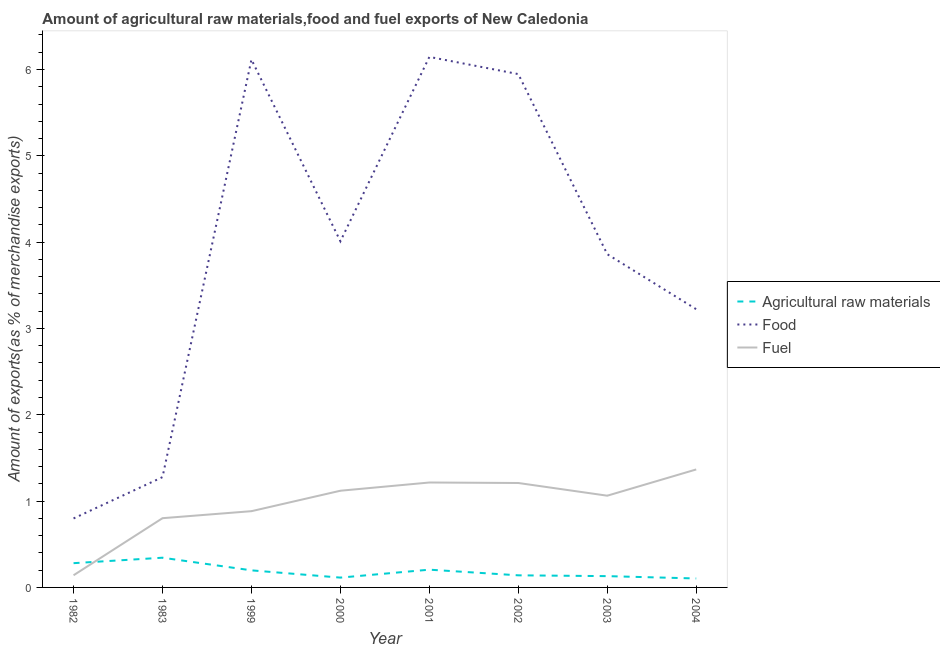How many different coloured lines are there?
Give a very brief answer. 3. Does the line corresponding to percentage of raw materials exports intersect with the line corresponding to percentage of food exports?
Keep it short and to the point. No. Is the number of lines equal to the number of legend labels?
Your answer should be compact. Yes. What is the percentage of fuel exports in 1982?
Your answer should be compact. 0.14. Across all years, what is the maximum percentage of raw materials exports?
Provide a succinct answer. 0.34. Across all years, what is the minimum percentage of raw materials exports?
Offer a terse response. 0.1. In which year was the percentage of food exports maximum?
Your answer should be compact. 2001. What is the total percentage of raw materials exports in the graph?
Provide a short and direct response. 1.52. What is the difference between the percentage of fuel exports in 2000 and that in 2004?
Ensure brevity in your answer.  -0.25. What is the difference between the percentage of raw materials exports in 2003 and the percentage of fuel exports in 2000?
Offer a very short reply. -0.99. What is the average percentage of food exports per year?
Your answer should be compact. 3.92. In the year 2001, what is the difference between the percentage of raw materials exports and percentage of fuel exports?
Make the answer very short. -1.01. In how many years, is the percentage of food exports greater than 1 %?
Provide a short and direct response. 7. What is the ratio of the percentage of food exports in 1999 to that in 2000?
Make the answer very short. 1.53. Is the percentage of fuel exports in 1983 less than that in 2002?
Offer a very short reply. Yes. What is the difference between the highest and the second highest percentage of food exports?
Your response must be concise. 0.03. What is the difference between the highest and the lowest percentage of raw materials exports?
Provide a short and direct response. 0.24. Is the sum of the percentage of raw materials exports in 2001 and 2002 greater than the maximum percentage of food exports across all years?
Offer a terse response. No. Does the percentage of food exports monotonically increase over the years?
Your response must be concise. No. Is the percentage of raw materials exports strictly greater than the percentage of food exports over the years?
Offer a terse response. No. How many lines are there?
Your answer should be compact. 3. Are the values on the major ticks of Y-axis written in scientific E-notation?
Your answer should be very brief. No. Does the graph contain any zero values?
Your response must be concise. No. Where does the legend appear in the graph?
Ensure brevity in your answer.  Center right. How are the legend labels stacked?
Provide a succinct answer. Vertical. What is the title of the graph?
Give a very brief answer. Amount of agricultural raw materials,food and fuel exports of New Caledonia. Does "Self-employed" appear as one of the legend labels in the graph?
Your answer should be very brief. No. What is the label or title of the X-axis?
Offer a terse response. Year. What is the label or title of the Y-axis?
Give a very brief answer. Amount of exports(as % of merchandise exports). What is the Amount of exports(as % of merchandise exports) in Agricultural raw materials in 1982?
Offer a terse response. 0.28. What is the Amount of exports(as % of merchandise exports) in Food in 1982?
Make the answer very short. 0.8. What is the Amount of exports(as % of merchandise exports) in Fuel in 1982?
Ensure brevity in your answer.  0.14. What is the Amount of exports(as % of merchandise exports) in Agricultural raw materials in 1983?
Ensure brevity in your answer.  0.34. What is the Amount of exports(as % of merchandise exports) of Food in 1983?
Your answer should be very brief. 1.28. What is the Amount of exports(as % of merchandise exports) of Fuel in 1983?
Give a very brief answer. 0.8. What is the Amount of exports(as % of merchandise exports) in Agricultural raw materials in 1999?
Ensure brevity in your answer.  0.2. What is the Amount of exports(as % of merchandise exports) of Food in 1999?
Ensure brevity in your answer.  6.12. What is the Amount of exports(as % of merchandise exports) in Fuel in 1999?
Offer a very short reply. 0.88. What is the Amount of exports(as % of merchandise exports) of Agricultural raw materials in 2000?
Your answer should be very brief. 0.11. What is the Amount of exports(as % of merchandise exports) in Food in 2000?
Provide a short and direct response. 4.01. What is the Amount of exports(as % of merchandise exports) of Fuel in 2000?
Your answer should be compact. 1.12. What is the Amount of exports(as % of merchandise exports) of Agricultural raw materials in 2001?
Provide a short and direct response. 0.21. What is the Amount of exports(as % of merchandise exports) in Food in 2001?
Keep it short and to the point. 6.15. What is the Amount of exports(as % of merchandise exports) in Fuel in 2001?
Keep it short and to the point. 1.22. What is the Amount of exports(as % of merchandise exports) in Agricultural raw materials in 2002?
Provide a succinct answer. 0.14. What is the Amount of exports(as % of merchandise exports) of Food in 2002?
Ensure brevity in your answer.  5.95. What is the Amount of exports(as % of merchandise exports) in Fuel in 2002?
Your answer should be compact. 1.21. What is the Amount of exports(as % of merchandise exports) in Agricultural raw materials in 2003?
Provide a succinct answer. 0.13. What is the Amount of exports(as % of merchandise exports) of Food in 2003?
Give a very brief answer. 3.86. What is the Amount of exports(as % of merchandise exports) in Fuel in 2003?
Provide a succinct answer. 1.06. What is the Amount of exports(as % of merchandise exports) in Agricultural raw materials in 2004?
Ensure brevity in your answer.  0.1. What is the Amount of exports(as % of merchandise exports) of Food in 2004?
Your response must be concise. 3.22. What is the Amount of exports(as % of merchandise exports) in Fuel in 2004?
Offer a very short reply. 1.37. Across all years, what is the maximum Amount of exports(as % of merchandise exports) in Agricultural raw materials?
Ensure brevity in your answer.  0.34. Across all years, what is the maximum Amount of exports(as % of merchandise exports) of Food?
Your answer should be compact. 6.15. Across all years, what is the maximum Amount of exports(as % of merchandise exports) in Fuel?
Provide a short and direct response. 1.37. Across all years, what is the minimum Amount of exports(as % of merchandise exports) in Agricultural raw materials?
Your answer should be compact. 0.1. Across all years, what is the minimum Amount of exports(as % of merchandise exports) of Food?
Your response must be concise. 0.8. Across all years, what is the minimum Amount of exports(as % of merchandise exports) in Fuel?
Give a very brief answer. 0.14. What is the total Amount of exports(as % of merchandise exports) of Agricultural raw materials in the graph?
Ensure brevity in your answer.  1.52. What is the total Amount of exports(as % of merchandise exports) of Food in the graph?
Keep it short and to the point. 31.38. What is the total Amount of exports(as % of merchandise exports) of Fuel in the graph?
Give a very brief answer. 7.8. What is the difference between the Amount of exports(as % of merchandise exports) in Agricultural raw materials in 1982 and that in 1983?
Make the answer very short. -0.06. What is the difference between the Amount of exports(as % of merchandise exports) of Food in 1982 and that in 1983?
Offer a terse response. -0.48. What is the difference between the Amount of exports(as % of merchandise exports) of Fuel in 1982 and that in 1983?
Offer a very short reply. -0.66. What is the difference between the Amount of exports(as % of merchandise exports) of Agricultural raw materials in 1982 and that in 1999?
Offer a very short reply. 0.08. What is the difference between the Amount of exports(as % of merchandise exports) in Food in 1982 and that in 1999?
Offer a terse response. -5.32. What is the difference between the Amount of exports(as % of merchandise exports) in Fuel in 1982 and that in 1999?
Offer a terse response. -0.74. What is the difference between the Amount of exports(as % of merchandise exports) in Agricultural raw materials in 1982 and that in 2000?
Your response must be concise. 0.17. What is the difference between the Amount of exports(as % of merchandise exports) in Food in 1982 and that in 2000?
Give a very brief answer. -3.21. What is the difference between the Amount of exports(as % of merchandise exports) of Fuel in 1982 and that in 2000?
Provide a succinct answer. -0.98. What is the difference between the Amount of exports(as % of merchandise exports) in Agricultural raw materials in 1982 and that in 2001?
Provide a short and direct response. 0.08. What is the difference between the Amount of exports(as % of merchandise exports) of Food in 1982 and that in 2001?
Ensure brevity in your answer.  -5.35. What is the difference between the Amount of exports(as % of merchandise exports) in Fuel in 1982 and that in 2001?
Give a very brief answer. -1.07. What is the difference between the Amount of exports(as % of merchandise exports) in Agricultural raw materials in 1982 and that in 2002?
Your response must be concise. 0.14. What is the difference between the Amount of exports(as % of merchandise exports) in Food in 1982 and that in 2002?
Ensure brevity in your answer.  -5.15. What is the difference between the Amount of exports(as % of merchandise exports) in Fuel in 1982 and that in 2002?
Your answer should be very brief. -1.07. What is the difference between the Amount of exports(as % of merchandise exports) in Agricultural raw materials in 1982 and that in 2003?
Ensure brevity in your answer.  0.15. What is the difference between the Amount of exports(as % of merchandise exports) in Food in 1982 and that in 2003?
Give a very brief answer. -3.06. What is the difference between the Amount of exports(as % of merchandise exports) of Fuel in 1982 and that in 2003?
Offer a very short reply. -0.92. What is the difference between the Amount of exports(as % of merchandise exports) of Agricultural raw materials in 1982 and that in 2004?
Offer a very short reply. 0.18. What is the difference between the Amount of exports(as % of merchandise exports) of Food in 1982 and that in 2004?
Provide a succinct answer. -2.42. What is the difference between the Amount of exports(as % of merchandise exports) in Fuel in 1982 and that in 2004?
Offer a very short reply. -1.23. What is the difference between the Amount of exports(as % of merchandise exports) in Agricultural raw materials in 1983 and that in 1999?
Offer a terse response. 0.15. What is the difference between the Amount of exports(as % of merchandise exports) in Food in 1983 and that in 1999?
Provide a short and direct response. -4.84. What is the difference between the Amount of exports(as % of merchandise exports) of Fuel in 1983 and that in 1999?
Offer a very short reply. -0.08. What is the difference between the Amount of exports(as % of merchandise exports) in Agricultural raw materials in 1983 and that in 2000?
Keep it short and to the point. 0.23. What is the difference between the Amount of exports(as % of merchandise exports) in Food in 1983 and that in 2000?
Provide a short and direct response. -2.73. What is the difference between the Amount of exports(as % of merchandise exports) in Fuel in 1983 and that in 2000?
Your response must be concise. -0.32. What is the difference between the Amount of exports(as % of merchandise exports) in Agricultural raw materials in 1983 and that in 2001?
Your response must be concise. 0.14. What is the difference between the Amount of exports(as % of merchandise exports) in Food in 1983 and that in 2001?
Your response must be concise. -4.87. What is the difference between the Amount of exports(as % of merchandise exports) in Fuel in 1983 and that in 2001?
Keep it short and to the point. -0.41. What is the difference between the Amount of exports(as % of merchandise exports) in Agricultural raw materials in 1983 and that in 2002?
Your answer should be very brief. 0.2. What is the difference between the Amount of exports(as % of merchandise exports) in Food in 1983 and that in 2002?
Keep it short and to the point. -4.67. What is the difference between the Amount of exports(as % of merchandise exports) of Fuel in 1983 and that in 2002?
Keep it short and to the point. -0.41. What is the difference between the Amount of exports(as % of merchandise exports) in Agricultural raw materials in 1983 and that in 2003?
Provide a succinct answer. 0.21. What is the difference between the Amount of exports(as % of merchandise exports) in Food in 1983 and that in 2003?
Provide a short and direct response. -2.58. What is the difference between the Amount of exports(as % of merchandise exports) of Fuel in 1983 and that in 2003?
Offer a terse response. -0.26. What is the difference between the Amount of exports(as % of merchandise exports) of Agricultural raw materials in 1983 and that in 2004?
Offer a terse response. 0.24. What is the difference between the Amount of exports(as % of merchandise exports) in Food in 1983 and that in 2004?
Make the answer very short. -1.95. What is the difference between the Amount of exports(as % of merchandise exports) of Fuel in 1983 and that in 2004?
Keep it short and to the point. -0.56. What is the difference between the Amount of exports(as % of merchandise exports) in Agricultural raw materials in 1999 and that in 2000?
Ensure brevity in your answer.  0.08. What is the difference between the Amount of exports(as % of merchandise exports) of Food in 1999 and that in 2000?
Keep it short and to the point. 2.11. What is the difference between the Amount of exports(as % of merchandise exports) of Fuel in 1999 and that in 2000?
Keep it short and to the point. -0.24. What is the difference between the Amount of exports(as % of merchandise exports) of Agricultural raw materials in 1999 and that in 2001?
Give a very brief answer. -0.01. What is the difference between the Amount of exports(as % of merchandise exports) of Food in 1999 and that in 2001?
Your answer should be compact. -0.03. What is the difference between the Amount of exports(as % of merchandise exports) of Fuel in 1999 and that in 2001?
Make the answer very short. -0.33. What is the difference between the Amount of exports(as % of merchandise exports) in Agricultural raw materials in 1999 and that in 2002?
Ensure brevity in your answer.  0.06. What is the difference between the Amount of exports(as % of merchandise exports) in Food in 1999 and that in 2002?
Make the answer very short. 0.17. What is the difference between the Amount of exports(as % of merchandise exports) of Fuel in 1999 and that in 2002?
Provide a short and direct response. -0.33. What is the difference between the Amount of exports(as % of merchandise exports) in Agricultural raw materials in 1999 and that in 2003?
Provide a short and direct response. 0.07. What is the difference between the Amount of exports(as % of merchandise exports) in Food in 1999 and that in 2003?
Your answer should be compact. 2.26. What is the difference between the Amount of exports(as % of merchandise exports) of Fuel in 1999 and that in 2003?
Make the answer very short. -0.18. What is the difference between the Amount of exports(as % of merchandise exports) of Agricultural raw materials in 1999 and that in 2004?
Provide a short and direct response. 0.09. What is the difference between the Amount of exports(as % of merchandise exports) of Food in 1999 and that in 2004?
Make the answer very short. 2.89. What is the difference between the Amount of exports(as % of merchandise exports) of Fuel in 1999 and that in 2004?
Give a very brief answer. -0.48. What is the difference between the Amount of exports(as % of merchandise exports) of Agricultural raw materials in 2000 and that in 2001?
Your answer should be very brief. -0.09. What is the difference between the Amount of exports(as % of merchandise exports) of Food in 2000 and that in 2001?
Your answer should be very brief. -2.14. What is the difference between the Amount of exports(as % of merchandise exports) of Fuel in 2000 and that in 2001?
Make the answer very short. -0.1. What is the difference between the Amount of exports(as % of merchandise exports) in Agricultural raw materials in 2000 and that in 2002?
Make the answer very short. -0.03. What is the difference between the Amount of exports(as % of merchandise exports) in Food in 2000 and that in 2002?
Provide a short and direct response. -1.94. What is the difference between the Amount of exports(as % of merchandise exports) in Fuel in 2000 and that in 2002?
Provide a succinct answer. -0.09. What is the difference between the Amount of exports(as % of merchandise exports) in Agricultural raw materials in 2000 and that in 2003?
Your response must be concise. -0.02. What is the difference between the Amount of exports(as % of merchandise exports) of Food in 2000 and that in 2003?
Your answer should be very brief. 0.15. What is the difference between the Amount of exports(as % of merchandise exports) in Fuel in 2000 and that in 2003?
Ensure brevity in your answer.  0.06. What is the difference between the Amount of exports(as % of merchandise exports) of Agricultural raw materials in 2000 and that in 2004?
Ensure brevity in your answer.  0.01. What is the difference between the Amount of exports(as % of merchandise exports) in Food in 2000 and that in 2004?
Give a very brief answer. 0.79. What is the difference between the Amount of exports(as % of merchandise exports) of Fuel in 2000 and that in 2004?
Your answer should be very brief. -0.25. What is the difference between the Amount of exports(as % of merchandise exports) of Agricultural raw materials in 2001 and that in 2002?
Your answer should be very brief. 0.07. What is the difference between the Amount of exports(as % of merchandise exports) in Food in 2001 and that in 2002?
Make the answer very short. 0.2. What is the difference between the Amount of exports(as % of merchandise exports) in Fuel in 2001 and that in 2002?
Your response must be concise. 0.01. What is the difference between the Amount of exports(as % of merchandise exports) in Agricultural raw materials in 2001 and that in 2003?
Give a very brief answer. 0.07. What is the difference between the Amount of exports(as % of merchandise exports) in Food in 2001 and that in 2003?
Offer a very short reply. 2.29. What is the difference between the Amount of exports(as % of merchandise exports) of Fuel in 2001 and that in 2003?
Offer a very short reply. 0.15. What is the difference between the Amount of exports(as % of merchandise exports) in Agricultural raw materials in 2001 and that in 2004?
Your response must be concise. 0.1. What is the difference between the Amount of exports(as % of merchandise exports) of Food in 2001 and that in 2004?
Give a very brief answer. 2.92. What is the difference between the Amount of exports(as % of merchandise exports) in Fuel in 2001 and that in 2004?
Offer a very short reply. -0.15. What is the difference between the Amount of exports(as % of merchandise exports) of Agricultural raw materials in 2002 and that in 2003?
Provide a short and direct response. 0.01. What is the difference between the Amount of exports(as % of merchandise exports) in Food in 2002 and that in 2003?
Your answer should be compact. 2.09. What is the difference between the Amount of exports(as % of merchandise exports) of Fuel in 2002 and that in 2003?
Keep it short and to the point. 0.15. What is the difference between the Amount of exports(as % of merchandise exports) in Agricultural raw materials in 2002 and that in 2004?
Provide a short and direct response. 0.04. What is the difference between the Amount of exports(as % of merchandise exports) in Food in 2002 and that in 2004?
Give a very brief answer. 2.72. What is the difference between the Amount of exports(as % of merchandise exports) in Fuel in 2002 and that in 2004?
Ensure brevity in your answer.  -0.16. What is the difference between the Amount of exports(as % of merchandise exports) of Agricultural raw materials in 2003 and that in 2004?
Provide a succinct answer. 0.03. What is the difference between the Amount of exports(as % of merchandise exports) of Food in 2003 and that in 2004?
Offer a terse response. 0.64. What is the difference between the Amount of exports(as % of merchandise exports) of Fuel in 2003 and that in 2004?
Offer a very short reply. -0.3. What is the difference between the Amount of exports(as % of merchandise exports) of Agricultural raw materials in 1982 and the Amount of exports(as % of merchandise exports) of Food in 1983?
Give a very brief answer. -1. What is the difference between the Amount of exports(as % of merchandise exports) in Agricultural raw materials in 1982 and the Amount of exports(as % of merchandise exports) in Fuel in 1983?
Offer a very short reply. -0.52. What is the difference between the Amount of exports(as % of merchandise exports) of Food in 1982 and the Amount of exports(as % of merchandise exports) of Fuel in 1983?
Offer a terse response. -0. What is the difference between the Amount of exports(as % of merchandise exports) in Agricultural raw materials in 1982 and the Amount of exports(as % of merchandise exports) in Food in 1999?
Provide a short and direct response. -5.83. What is the difference between the Amount of exports(as % of merchandise exports) in Agricultural raw materials in 1982 and the Amount of exports(as % of merchandise exports) in Fuel in 1999?
Keep it short and to the point. -0.6. What is the difference between the Amount of exports(as % of merchandise exports) of Food in 1982 and the Amount of exports(as % of merchandise exports) of Fuel in 1999?
Keep it short and to the point. -0.08. What is the difference between the Amount of exports(as % of merchandise exports) in Agricultural raw materials in 1982 and the Amount of exports(as % of merchandise exports) in Food in 2000?
Your answer should be compact. -3.73. What is the difference between the Amount of exports(as % of merchandise exports) of Agricultural raw materials in 1982 and the Amount of exports(as % of merchandise exports) of Fuel in 2000?
Give a very brief answer. -0.84. What is the difference between the Amount of exports(as % of merchandise exports) of Food in 1982 and the Amount of exports(as % of merchandise exports) of Fuel in 2000?
Keep it short and to the point. -0.32. What is the difference between the Amount of exports(as % of merchandise exports) of Agricultural raw materials in 1982 and the Amount of exports(as % of merchandise exports) of Food in 2001?
Your response must be concise. -5.87. What is the difference between the Amount of exports(as % of merchandise exports) in Agricultural raw materials in 1982 and the Amount of exports(as % of merchandise exports) in Fuel in 2001?
Give a very brief answer. -0.93. What is the difference between the Amount of exports(as % of merchandise exports) of Food in 1982 and the Amount of exports(as % of merchandise exports) of Fuel in 2001?
Ensure brevity in your answer.  -0.42. What is the difference between the Amount of exports(as % of merchandise exports) of Agricultural raw materials in 1982 and the Amount of exports(as % of merchandise exports) of Food in 2002?
Offer a very short reply. -5.67. What is the difference between the Amount of exports(as % of merchandise exports) in Agricultural raw materials in 1982 and the Amount of exports(as % of merchandise exports) in Fuel in 2002?
Offer a very short reply. -0.93. What is the difference between the Amount of exports(as % of merchandise exports) in Food in 1982 and the Amount of exports(as % of merchandise exports) in Fuel in 2002?
Offer a very short reply. -0.41. What is the difference between the Amount of exports(as % of merchandise exports) of Agricultural raw materials in 1982 and the Amount of exports(as % of merchandise exports) of Food in 2003?
Your response must be concise. -3.58. What is the difference between the Amount of exports(as % of merchandise exports) of Agricultural raw materials in 1982 and the Amount of exports(as % of merchandise exports) of Fuel in 2003?
Give a very brief answer. -0.78. What is the difference between the Amount of exports(as % of merchandise exports) of Food in 1982 and the Amount of exports(as % of merchandise exports) of Fuel in 2003?
Ensure brevity in your answer.  -0.26. What is the difference between the Amount of exports(as % of merchandise exports) of Agricultural raw materials in 1982 and the Amount of exports(as % of merchandise exports) of Food in 2004?
Ensure brevity in your answer.  -2.94. What is the difference between the Amount of exports(as % of merchandise exports) in Agricultural raw materials in 1982 and the Amount of exports(as % of merchandise exports) in Fuel in 2004?
Provide a short and direct response. -1.09. What is the difference between the Amount of exports(as % of merchandise exports) of Food in 1982 and the Amount of exports(as % of merchandise exports) of Fuel in 2004?
Your answer should be compact. -0.57. What is the difference between the Amount of exports(as % of merchandise exports) in Agricultural raw materials in 1983 and the Amount of exports(as % of merchandise exports) in Food in 1999?
Offer a terse response. -5.77. What is the difference between the Amount of exports(as % of merchandise exports) of Agricultural raw materials in 1983 and the Amount of exports(as % of merchandise exports) of Fuel in 1999?
Your answer should be very brief. -0.54. What is the difference between the Amount of exports(as % of merchandise exports) in Food in 1983 and the Amount of exports(as % of merchandise exports) in Fuel in 1999?
Give a very brief answer. 0.39. What is the difference between the Amount of exports(as % of merchandise exports) in Agricultural raw materials in 1983 and the Amount of exports(as % of merchandise exports) in Food in 2000?
Offer a terse response. -3.67. What is the difference between the Amount of exports(as % of merchandise exports) in Agricultural raw materials in 1983 and the Amount of exports(as % of merchandise exports) in Fuel in 2000?
Ensure brevity in your answer.  -0.78. What is the difference between the Amount of exports(as % of merchandise exports) in Food in 1983 and the Amount of exports(as % of merchandise exports) in Fuel in 2000?
Your answer should be very brief. 0.16. What is the difference between the Amount of exports(as % of merchandise exports) of Agricultural raw materials in 1983 and the Amount of exports(as % of merchandise exports) of Food in 2001?
Your response must be concise. -5.8. What is the difference between the Amount of exports(as % of merchandise exports) in Agricultural raw materials in 1983 and the Amount of exports(as % of merchandise exports) in Fuel in 2001?
Provide a succinct answer. -0.87. What is the difference between the Amount of exports(as % of merchandise exports) in Food in 1983 and the Amount of exports(as % of merchandise exports) in Fuel in 2001?
Keep it short and to the point. 0.06. What is the difference between the Amount of exports(as % of merchandise exports) in Agricultural raw materials in 1983 and the Amount of exports(as % of merchandise exports) in Food in 2002?
Provide a succinct answer. -5.6. What is the difference between the Amount of exports(as % of merchandise exports) in Agricultural raw materials in 1983 and the Amount of exports(as % of merchandise exports) in Fuel in 2002?
Your answer should be compact. -0.87. What is the difference between the Amount of exports(as % of merchandise exports) in Food in 1983 and the Amount of exports(as % of merchandise exports) in Fuel in 2002?
Your answer should be compact. 0.07. What is the difference between the Amount of exports(as % of merchandise exports) in Agricultural raw materials in 1983 and the Amount of exports(as % of merchandise exports) in Food in 2003?
Provide a succinct answer. -3.52. What is the difference between the Amount of exports(as % of merchandise exports) of Agricultural raw materials in 1983 and the Amount of exports(as % of merchandise exports) of Fuel in 2003?
Keep it short and to the point. -0.72. What is the difference between the Amount of exports(as % of merchandise exports) of Food in 1983 and the Amount of exports(as % of merchandise exports) of Fuel in 2003?
Give a very brief answer. 0.22. What is the difference between the Amount of exports(as % of merchandise exports) in Agricultural raw materials in 1983 and the Amount of exports(as % of merchandise exports) in Food in 2004?
Your answer should be compact. -2.88. What is the difference between the Amount of exports(as % of merchandise exports) of Agricultural raw materials in 1983 and the Amount of exports(as % of merchandise exports) of Fuel in 2004?
Provide a succinct answer. -1.02. What is the difference between the Amount of exports(as % of merchandise exports) in Food in 1983 and the Amount of exports(as % of merchandise exports) in Fuel in 2004?
Give a very brief answer. -0.09. What is the difference between the Amount of exports(as % of merchandise exports) in Agricultural raw materials in 1999 and the Amount of exports(as % of merchandise exports) in Food in 2000?
Keep it short and to the point. -3.81. What is the difference between the Amount of exports(as % of merchandise exports) of Agricultural raw materials in 1999 and the Amount of exports(as % of merchandise exports) of Fuel in 2000?
Provide a succinct answer. -0.92. What is the difference between the Amount of exports(as % of merchandise exports) in Food in 1999 and the Amount of exports(as % of merchandise exports) in Fuel in 2000?
Ensure brevity in your answer.  5. What is the difference between the Amount of exports(as % of merchandise exports) in Agricultural raw materials in 1999 and the Amount of exports(as % of merchandise exports) in Food in 2001?
Ensure brevity in your answer.  -5.95. What is the difference between the Amount of exports(as % of merchandise exports) of Agricultural raw materials in 1999 and the Amount of exports(as % of merchandise exports) of Fuel in 2001?
Your answer should be compact. -1.02. What is the difference between the Amount of exports(as % of merchandise exports) in Food in 1999 and the Amount of exports(as % of merchandise exports) in Fuel in 2001?
Offer a very short reply. 4.9. What is the difference between the Amount of exports(as % of merchandise exports) of Agricultural raw materials in 1999 and the Amount of exports(as % of merchandise exports) of Food in 2002?
Provide a succinct answer. -5.75. What is the difference between the Amount of exports(as % of merchandise exports) in Agricultural raw materials in 1999 and the Amount of exports(as % of merchandise exports) in Fuel in 2002?
Provide a short and direct response. -1.01. What is the difference between the Amount of exports(as % of merchandise exports) in Food in 1999 and the Amount of exports(as % of merchandise exports) in Fuel in 2002?
Your answer should be compact. 4.91. What is the difference between the Amount of exports(as % of merchandise exports) of Agricultural raw materials in 1999 and the Amount of exports(as % of merchandise exports) of Food in 2003?
Your answer should be very brief. -3.66. What is the difference between the Amount of exports(as % of merchandise exports) in Agricultural raw materials in 1999 and the Amount of exports(as % of merchandise exports) in Fuel in 2003?
Your response must be concise. -0.86. What is the difference between the Amount of exports(as % of merchandise exports) of Food in 1999 and the Amount of exports(as % of merchandise exports) of Fuel in 2003?
Keep it short and to the point. 5.05. What is the difference between the Amount of exports(as % of merchandise exports) of Agricultural raw materials in 1999 and the Amount of exports(as % of merchandise exports) of Food in 2004?
Provide a succinct answer. -3.03. What is the difference between the Amount of exports(as % of merchandise exports) in Agricultural raw materials in 1999 and the Amount of exports(as % of merchandise exports) in Fuel in 2004?
Your answer should be compact. -1.17. What is the difference between the Amount of exports(as % of merchandise exports) of Food in 1999 and the Amount of exports(as % of merchandise exports) of Fuel in 2004?
Provide a succinct answer. 4.75. What is the difference between the Amount of exports(as % of merchandise exports) in Agricultural raw materials in 2000 and the Amount of exports(as % of merchandise exports) in Food in 2001?
Your response must be concise. -6.03. What is the difference between the Amount of exports(as % of merchandise exports) in Agricultural raw materials in 2000 and the Amount of exports(as % of merchandise exports) in Fuel in 2001?
Your response must be concise. -1.1. What is the difference between the Amount of exports(as % of merchandise exports) of Food in 2000 and the Amount of exports(as % of merchandise exports) of Fuel in 2001?
Provide a succinct answer. 2.79. What is the difference between the Amount of exports(as % of merchandise exports) in Agricultural raw materials in 2000 and the Amount of exports(as % of merchandise exports) in Food in 2002?
Ensure brevity in your answer.  -5.83. What is the difference between the Amount of exports(as % of merchandise exports) of Agricultural raw materials in 2000 and the Amount of exports(as % of merchandise exports) of Fuel in 2002?
Ensure brevity in your answer.  -1.1. What is the difference between the Amount of exports(as % of merchandise exports) in Food in 2000 and the Amount of exports(as % of merchandise exports) in Fuel in 2002?
Make the answer very short. 2.8. What is the difference between the Amount of exports(as % of merchandise exports) of Agricultural raw materials in 2000 and the Amount of exports(as % of merchandise exports) of Food in 2003?
Your answer should be very brief. -3.75. What is the difference between the Amount of exports(as % of merchandise exports) in Agricultural raw materials in 2000 and the Amount of exports(as % of merchandise exports) in Fuel in 2003?
Keep it short and to the point. -0.95. What is the difference between the Amount of exports(as % of merchandise exports) of Food in 2000 and the Amount of exports(as % of merchandise exports) of Fuel in 2003?
Provide a succinct answer. 2.95. What is the difference between the Amount of exports(as % of merchandise exports) of Agricultural raw materials in 2000 and the Amount of exports(as % of merchandise exports) of Food in 2004?
Keep it short and to the point. -3.11. What is the difference between the Amount of exports(as % of merchandise exports) of Agricultural raw materials in 2000 and the Amount of exports(as % of merchandise exports) of Fuel in 2004?
Ensure brevity in your answer.  -1.25. What is the difference between the Amount of exports(as % of merchandise exports) in Food in 2000 and the Amount of exports(as % of merchandise exports) in Fuel in 2004?
Your answer should be very brief. 2.64. What is the difference between the Amount of exports(as % of merchandise exports) in Agricultural raw materials in 2001 and the Amount of exports(as % of merchandise exports) in Food in 2002?
Make the answer very short. -5.74. What is the difference between the Amount of exports(as % of merchandise exports) in Agricultural raw materials in 2001 and the Amount of exports(as % of merchandise exports) in Fuel in 2002?
Keep it short and to the point. -1. What is the difference between the Amount of exports(as % of merchandise exports) in Food in 2001 and the Amount of exports(as % of merchandise exports) in Fuel in 2002?
Provide a succinct answer. 4.94. What is the difference between the Amount of exports(as % of merchandise exports) in Agricultural raw materials in 2001 and the Amount of exports(as % of merchandise exports) in Food in 2003?
Ensure brevity in your answer.  -3.65. What is the difference between the Amount of exports(as % of merchandise exports) of Agricultural raw materials in 2001 and the Amount of exports(as % of merchandise exports) of Fuel in 2003?
Give a very brief answer. -0.86. What is the difference between the Amount of exports(as % of merchandise exports) in Food in 2001 and the Amount of exports(as % of merchandise exports) in Fuel in 2003?
Make the answer very short. 5.08. What is the difference between the Amount of exports(as % of merchandise exports) of Agricultural raw materials in 2001 and the Amount of exports(as % of merchandise exports) of Food in 2004?
Give a very brief answer. -3.02. What is the difference between the Amount of exports(as % of merchandise exports) in Agricultural raw materials in 2001 and the Amount of exports(as % of merchandise exports) in Fuel in 2004?
Give a very brief answer. -1.16. What is the difference between the Amount of exports(as % of merchandise exports) in Food in 2001 and the Amount of exports(as % of merchandise exports) in Fuel in 2004?
Keep it short and to the point. 4.78. What is the difference between the Amount of exports(as % of merchandise exports) of Agricultural raw materials in 2002 and the Amount of exports(as % of merchandise exports) of Food in 2003?
Your answer should be very brief. -3.72. What is the difference between the Amount of exports(as % of merchandise exports) of Agricultural raw materials in 2002 and the Amount of exports(as % of merchandise exports) of Fuel in 2003?
Your answer should be compact. -0.92. What is the difference between the Amount of exports(as % of merchandise exports) of Food in 2002 and the Amount of exports(as % of merchandise exports) of Fuel in 2003?
Offer a very short reply. 4.88. What is the difference between the Amount of exports(as % of merchandise exports) of Agricultural raw materials in 2002 and the Amount of exports(as % of merchandise exports) of Food in 2004?
Provide a succinct answer. -3.08. What is the difference between the Amount of exports(as % of merchandise exports) in Agricultural raw materials in 2002 and the Amount of exports(as % of merchandise exports) in Fuel in 2004?
Your response must be concise. -1.23. What is the difference between the Amount of exports(as % of merchandise exports) in Food in 2002 and the Amount of exports(as % of merchandise exports) in Fuel in 2004?
Provide a short and direct response. 4.58. What is the difference between the Amount of exports(as % of merchandise exports) of Agricultural raw materials in 2003 and the Amount of exports(as % of merchandise exports) of Food in 2004?
Provide a succinct answer. -3.09. What is the difference between the Amount of exports(as % of merchandise exports) in Agricultural raw materials in 2003 and the Amount of exports(as % of merchandise exports) in Fuel in 2004?
Offer a very short reply. -1.24. What is the difference between the Amount of exports(as % of merchandise exports) of Food in 2003 and the Amount of exports(as % of merchandise exports) of Fuel in 2004?
Provide a succinct answer. 2.49. What is the average Amount of exports(as % of merchandise exports) of Agricultural raw materials per year?
Offer a very short reply. 0.19. What is the average Amount of exports(as % of merchandise exports) in Food per year?
Give a very brief answer. 3.92. What is the average Amount of exports(as % of merchandise exports) in Fuel per year?
Offer a terse response. 0.98. In the year 1982, what is the difference between the Amount of exports(as % of merchandise exports) in Agricultural raw materials and Amount of exports(as % of merchandise exports) in Food?
Your answer should be compact. -0.52. In the year 1982, what is the difference between the Amount of exports(as % of merchandise exports) in Agricultural raw materials and Amount of exports(as % of merchandise exports) in Fuel?
Provide a short and direct response. 0.14. In the year 1982, what is the difference between the Amount of exports(as % of merchandise exports) of Food and Amount of exports(as % of merchandise exports) of Fuel?
Ensure brevity in your answer.  0.66. In the year 1983, what is the difference between the Amount of exports(as % of merchandise exports) in Agricultural raw materials and Amount of exports(as % of merchandise exports) in Food?
Ensure brevity in your answer.  -0.93. In the year 1983, what is the difference between the Amount of exports(as % of merchandise exports) of Agricultural raw materials and Amount of exports(as % of merchandise exports) of Fuel?
Offer a terse response. -0.46. In the year 1983, what is the difference between the Amount of exports(as % of merchandise exports) of Food and Amount of exports(as % of merchandise exports) of Fuel?
Provide a succinct answer. 0.48. In the year 1999, what is the difference between the Amount of exports(as % of merchandise exports) in Agricultural raw materials and Amount of exports(as % of merchandise exports) in Food?
Your answer should be compact. -5.92. In the year 1999, what is the difference between the Amount of exports(as % of merchandise exports) in Agricultural raw materials and Amount of exports(as % of merchandise exports) in Fuel?
Your answer should be very brief. -0.69. In the year 1999, what is the difference between the Amount of exports(as % of merchandise exports) in Food and Amount of exports(as % of merchandise exports) in Fuel?
Your answer should be very brief. 5.23. In the year 2000, what is the difference between the Amount of exports(as % of merchandise exports) in Agricultural raw materials and Amount of exports(as % of merchandise exports) in Food?
Provide a succinct answer. -3.9. In the year 2000, what is the difference between the Amount of exports(as % of merchandise exports) of Agricultural raw materials and Amount of exports(as % of merchandise exports) of Fuel?
Offer a terse response. -1.01. In the year 2000, what is the difference between the Amount of exports(as % of merchandise exports) in Food and Amount of exports(as % of merchandise exports) in Fuel?
Offer a very short reply. 2.89. In the year 2001, what is the difference between the Amount of exports(as % of merchandise exports) in Agricultural raw materials and Amount of exports(as % of merchandise exports) in Food?
Offer a very short reply. -5.94. In the year 2001, what is the difference between the Amount of exports(as % of merchandise exports) in Agricultural raw materials and Amount of exports(as % of merchandise exports) in Fuel?
Offer a very short reply. -1.01. In the year 2001, what is the difference between the Amount of exports(as % of merchandise exports) of Food and Amount of exports(as % of merchandise exports) of Fuel?
Your answer should be compact. 4.93. In the year 2002, what is the difference between the Amount of exports(as % of merchandise exports) in Agricultural raw materials and Amount of exports(as % of merchandise exports) in Food?
Make the answer very short. -5.81. In the year 2002, what is the difference between the Amount of exports(as % of merchandise exports) of Agricultural raw materials and Amount of exports(as % of merchandise exports) of Fuel?
Ensure brevity in your answer.  -1.07. In the year 2002, what is the difference between the Amount of exports(as % of merchandise exports) in Food and Amount of exports(as % of merchandise exports) in Fuel?
Your answer should be very brief. 4.74. In the year 2003, what is the difference between the Amount of exports(as % of merchandise exports) of Agricultural raw materials and Amount of exports(as % of merchandise exports) of Food?
Give a very brief answer. -3.73. In the year 2003, what is the difference between the Amount of exports(as % of merchandise exports) in Agricultural raw materials and Amount of exports(as % of merchandise exports) in Fuel?
Offer a terse response. -0.93. In the year 2003, what is the difference between the Amount of exports(as % of merchandise exports) of Food and Amount of exports(as % of merchandise exports) of Fuel?
Offer a very short reply. 2.8. In the year 2004, what is the difference between the Amount of exports(as % of merchandise exports) in Agricultural raw materials and Amount of exports(as % of merchandise exports) in Food?
Make the answer very short. -3.12. In the year 2004, what is the difference between the Amount of exports(as % of merchandise exports) in Agricultural raw materials and Amount of exports(as % of merchandise exports) in Fuel?
Provide a short and direct response. -1.26. In the year 2004, what is the difference between the Amount of exports(as % of merchandise exports) in Food and Amount of exports(as % of merchandise exports) in Fuel?
Offer a terse response. 1.86. What is the ratio of the Amount of exports(as % of merchandise exports) in Agricultural raw materials in 1982 to that in 1983?
Provide a short and direct response. 0.82. What is the ratio of the Amount of exports(as % of merchandise exports) in Food in 1982 to that in 1983?
Your answer should be compact. 0.63. What is the ratio of the Amount of exports(as % of merchandise exports) in Fuel in 1982 to that in 1983?
Keep it short and to the point. 0.18. What is the ratio of the Amount of exports(as % of merchandise exports) in Agricultural raw materials in 1982 to that in 1999?
Offer a very short reply. 1.42. What is the ratio of the Amount of exports(as % of merchandise exports) in Food in 1982 to that in 1999?
Provide a short and direct response. 0.13. What is the ratio of the Amount of exports(as % of merchandise exports) in Fuel in 1982 to that in 1999?
Your answer should be compact. 0.16. What is the ratio of the Amount of exports(as % of merchandise exports) of Agricultural raw materials in 1982 to that in 2000?
Your answer should be compact. 2.47. What is the ratio of the Amount of exports(as % of merchandise exports) of Food in 1982 to that in 2000?
Offer a very short reply. 0.2. What is the ratio of the Amount of exports(as % of merchandise exports) in Fuel in 1982 to that in 2000?
Offer a terse response. 0.13. What is the ratio of the Amount of exports(as % of merchandise exports) in Agricultural raw materials in 1982 to that in 2001?
Provide a succinct answer. 1.37. What is the ratio of the Amount of exports(as % of merchandise exports) in Food in 1982 to that in 2001?
Your response must be concise. 0.13. What is the ratio of the Amount of exports(as % of merchandise exports) of Fuel in 1982 to that in 2001?
Provide a succinct answer. 0.12. What is the ratio of the Amount of exports(as % of merchandise exports) in Agricultural raw materials in 1982 to that in 2002?
Offer a terse response. 2. What is the ratio of the Amount of exports(as % of merchandise exports) in Food in 1982 to that in 2002?
Offer a very short reply. 0.13. What is the ratio of the Amount of exports(as % of merchandise exports) of Fuel in 1982 to that in 2002?
Provide a short and direct response. 0.12. What is the ratio of the Amount of exports(as % of merchandise exports) of Agricultural raw materials in 1982 to that in 2003?
Your answer should be compact. 2.15. What is the ratio of the Amount of exports(as % of merchandise exports) of Food in 1982 to that in 2003?
Your answer should be very brief. 0.21. What is the ratio of the Amount of exports(as % of merchandise exports) in Fuel in 1982 to that in 2003?
Give a very brief answer. 0.13. What is the ratio of the Amount of exports(as % of merchandise exports) in Agricultural raw materials in 1982 to that in 2004?
Offer a very short reply. 2.71. What is the ratio of the Amount of exports(as % of merchandise exports) in Food in 1982 to that in 2004?
Your response must be concise. 0.25. What is the ratio of the Amount of exports(as % of merchandise exports) in Fuel in 1982 to that in 2004?
Make the answer very short. 0.1. What is the ratio of the Amount of exports(as % of merchandise exports) in Agricultural raw materials in 1983 to that in 1999?
Keep it short and to the point. 1.74. What is the ratio of the Amount of exports(as % of merchandise exports) in Food in 1983 to that in 1999?
Your response must be concise. 0.21. What is the ratio of the Amount of exports(as % of merchandise exports) of Fuel in 1983 to that in 1999?
Your answer should be very brief. 0.91. What is the ratio of the Amount of exports(as % of merchandise exports) in Agricultural raw materials in 1983 to that in 2000?
Your answer should be very brief. 3.03. What is the ratio of the Amount of exports(as % of merchandise exports) of Food in 1983 to that in 2000?
Your answer should be compact. 0.32. What is the ratio of the Amount of exports(as % of merchandise exports) in Fuel in 1983 to that in 2000?
Keep it short and to the point. 0.72. What is the ratio of the Amount of exports(as % of merchandise exports) of Agricultural raw materials in 1983 to that in 2001?
Offer a terse response. 1.67. What is the ratio of the Amount of exports(as % of merchandise exports) of Food in 1983 to that in 2001?
Provide a succinct answer. 0.21. What is the ratio of the Amount of exports(as % of merchandise exports) of Fuel in 1983 to that in 2001?
Ensure brevity in your answer.  0.66. What is the ratio of the Amount of exports(as % of merchandise exports) of Agricultural raw materials in 1983 to that in 2002?
Provide a short and direct response. 2.46. What is the ratio of the Amount of exports(as % of merchandise exports) in Food in 1983 to that in 2002?
Provide a succinct answer. 0.21. What is the ratio of the Amount of exports(as % of merchandise exports) in Fuel in 1983 to that in 2002?
Your answer should be compact. 0.66. What is the ratio of the Amount of exports(as % of merchandise exports) of Agricultural raw materials in 1983 to that in 2003?
Offer a terse response. 2.63. What is the ratio of the Amount of exports(as % of merchandise exports) in Food in 1983 to that in 2003?
Provide a succinct answer. 0.33. What is the ratio of the Amount of exports(as % of merchandise exports) in Fuel in 1983 to that in 2003?
Give a very brief answer. 0.75. What is the ratio of the Amount of exports(as % of merchandise exports) in Agricultural raw materials in 1983 to that in 2004?
Give a very brief answer. 3.32. What is the ratio of the Amount of exports(as % of merchandise exports) of Food in 1983 to that in 2004?
Your answer should be very brief. 0.4. What is the ratio of the Amount of exports(as % of merchandise exports) of Fuel in 1983 to that in 2004?
Ensure brevity in your answer.  0.59. What is the ratio of the Amount of exports(as % of merchandise exports) in Agricultural raw materials in 1999 to that in 2000?
Your answer should be very brief. 1.74. What is the ratio of the Amount of exports(as % of merchandise exports) in Food in 1999 to that in 2000?
Ensure brevity in your answer.  1.53. What is the ratio of the Amount of exports(as % of merchandise exports) of Fuel in 1999 to that in 2000?
Your response must be concise. 0.79. What is the ratio of the Amount of exports(as % of merchandise exports) of Agricultural raw materials in 1999 to that in 2001?
Your answer should be very brief. 0.96. What is the ratio of the Amount of exports(as % of merchandise exports) in Food in 1999 to that in 2001?
Your answer should be very brief. 1. What is the ratio of the Amount of exports(as % of merchandise exports) in Fuel in 1999 to that in 2001?
Keep it short and to the point. 0.73. What is the ratio of the Amount of exports(as % of merchandise exports) of Agricultural raw materials in 1999 to that in 2002?
Give a very brief answer. 1.41. What is the ratio of the Amount of exports(as % of merchandise exports) in Food in 1999 to that in 2002?
Provide a short and direct response. 1.03. What is the ratio of the Amount of exports(as % of merchandise exports) in Fuel in 1999 to that in 2002?
Your response must be concise. 0.73. What is the ratio of the Amount of exports(as % of merchandise exports) in Agricultural raw materials in 1999 to that in 2003?
Your answer should be compact. 1.51. What is the ratio of the Amount of exports(as % of merchandise exports) in Food in 1999 to that in 2003?
Provide a short and direct response. 1.58. What is the ratio of the Amount of exports(as % of merchandise exports) in Fuel in 1999 to that in 2003?
Give a very brief answer. 0.83. What is the ratio of the Amount of exports(as % of merchandise exports) in Agricultural raw materials in 1999 to that in 2004?
Your answer should be very brief. 1.91. What is the ratio of the Amount of exports(as % of merchandise exports) in Food in 1999 to that in 2004?
Your response must be concise. 1.9. What is the ratio of the Amount of exports(as % of merchandise exports) of Fuel in 1999 to that in 2004?
Make the answer very short. 0.65. What is the ratio of the Amount of exports(as % of merchandise exports) in Agricultural raw materials in 2000 to that in 2001?
Offer a terse response. 0.55. What is the ratio of the Amount of exports(as % of merchandise exports) in Food in 2000 to that in 2001?
Give a very brief answer. 0.65. What is the ratio of the Amount of exports(as % of merchandise exports) of Fuel in 2000 to that in 2001?
Make the answer very short. 0.92. What is the ratio of the Amount of exports(as % of merchandise exports) of Agricultural raw materials in 2000 to that in 2002?
Ensure brevity in your answer.  0.81. What is the ratio of the Amount of exports(as % of merchandise exports) in Food in 2000 to that in 2002?
Provide a succinct answer. 0.67. What is the ratio of the Amount of exports(as % of merchandise exports) in Fuel in 2000 to that in 2002?
Your answer should be very brief. 0.93. What is the ratio of the Amount of exports(as % of merchandise exports) in Agricultural raw materials in 2000 to that in 2003?
Give a very brief answer. 0.87. What is the ratio of the Amount of exports(as % of merchandise exports) of Food in 2000 to that in 2003?
Keep it short and to the point. 1.04. What is the ratio of the Amount of exports(as % of merchandise exports) in Fuel in 2000 to that in 2003?
Keep it short and to the point. 1.05. What is the ratio of the Amount of exports(as % of merchandise exports) of Agricultural raw materials in 2000 to that in 2004?
Ensure brevity in your answer.  1.1. What is the ratio of the Amount of exports(as % of merchandise exports) in Food in 2000 to that in 2004?
Your response must be concise. 1.24. What is the ratio of the Amount of exports(as % of merchandise exports) of Fuel in 2000 to that in 2004?
Provide a succinct answer. 0.82. What is the ratio of the Amount of exports(as % of merchandise exports) in Agricultural raw materials in 2001 to that in 2002?
Provide a short and direct response. 1.47. What is the ratio of the Amount of exports(as % of merchandise exports) in Food in 2001 to that in 2002?
Provide a succinct answer. 1.03. What is the ratio of the Amount of exports(as % of merchandise exports) of Fuel in 2001 to that in 2002?
Your answer should be compact. 1. What is the ratio of the Amount of exports(as % of merchandise exports) of Agricultural raw materials in 2001 to that in 2003?
Your answer should be compact. 1.57. What is the ratio of the Amount of exports(as % of merchandise exports) in Food in 2001 to that in 2003?
Keep it short and to the point. 1.59. What is the ratio of the Amount of exports(as % of merchandise exports) in Fuel in 2001 to that in 2003?
Provide a short and direct response. 1.14. What is the ratio of the Amount of exports(as % of merchandise exports) of Agricultural raw materials in 2001 to that in 2004?
Provide a succinct answer. 1.98. What is the ratio of the Amount of exports(as % of merchandise exports) in Food in 2001 to that in 2004?
Give a very brief answer. 1.91. What is the ratio of the Amount of exports(as % of merchandise exports) of Fuel in 2001 to that in 2004?
Ensure brevity in your answer.  0.89. What is the ratio of the Amount of exports(as % of merchandise exports) of Agricultural raw materials in 2002 to that in 2003?
Your answer should be compact. 1.07. What is the ratio of the Amount of exports(as % of merchandise exports) in Food in 2002 to that in 2003?
Offer a terse response. 1.54. What is the ratio of the Amount of exports(as % of merchandise exports) of Fuel in 2002 to that in 2003?
Provide a short and direct response. 1.14. What is the ratio of the Amount of exports(as % of merchandise exports) in Agricultural raw materials in 2002 to that in 2004?
Ensure brevity in your answer.  1.35. What is the ratio of the Amount of exports(as % of merchandise exports) in Food in 2002 to that in 2004?
Ensure brevity in your answer.  1.85. What is the ratio of the Amount of exports(as % of merchandise exports) in Fuel in 2002 to that in 2004?
Make the answer very short. 0.89. What is the ratio of the Amount of exports(as % of merchandise exports) in Agricultural raw materials in 2003 to that in 2004?
Keep it short and to the point. 1.26. What is the ratio of the Amount of exports(as % of merchandise exports) in Food in 2003 to that in 2004?
Offer a very short reply. 1.2. What is the ratio of the Amount of exports(as % of merchandise exports) of Fuel in 2003 to that in 2004?
Keep it short and to the point. 0.78. What is the difference between the highest and the second highest Amount of exports(as % of merchandise exports) of Agricultural raw materials?
Offer a terse response. 0.06. What is the difference between the highest and the second highest Amount of exports(as % of merchandise exports) in Food?
Offer a terse response. 0.03. What is the difference between the highest and the second highest Amount of exports(as % of merchandise exports) in Fuel?
Offer a very short reply. 0.15. What is the difference between the highest and the lowest Amount of exports(as % of merchandise exports) in Agricultural raw materials?
Keep it short and to the point. 0.24. What is the difference between the highest and the lowest Amount of exports(as % of merchandise exports) of Food?
Ensure brevity in your answer.  5.35. What is the difference between the highest and the lowest Amount of exports(as % of merchandise exports) of Fuel?
Ensure brevity in your answer.  1.23. 